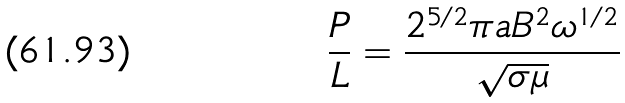Convert formula to latex. <formula><loc_0><loc_0><loc_500><loc_500>\frac { P } { L } = \frac { 2 ^ { 5 / 2 } \pi a B ^ { 2 } \omega ^ { 1 / 2 } } { \sqrt { \sigma \mu } }</formula> 